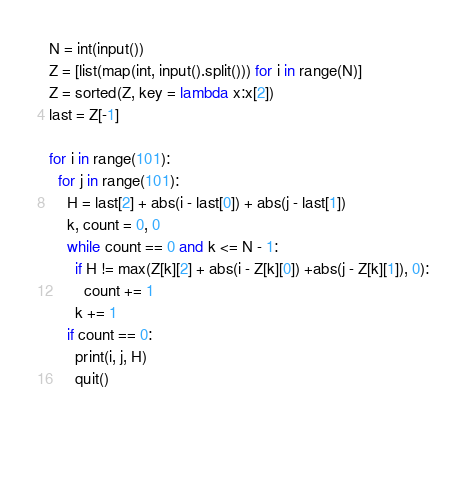Convert code to text. <code><loc_0><loc_0><loc_500><loc_500><_Python_>N = int(input())
Z = [list(map(int, input().split())) for i in range(N)]
Z = sorted(Z, key = lambda x:x[2])
last = Z[-1]

for i in range(101):
  for j in range(101):
    H = last[2] + abs(i - last[0]) + abs(j - last[1])
    k, count = 0, 0 
    while count == 0 and k <= N - 1:
      if H != max(Z[k][2] + abs(i - Z[k][0]) +abs(j - Z[k][1]), 0):
        count += 1
      k += 1
    if count == 0:
      print(i, j, H)
      quit()

  
        </code> 